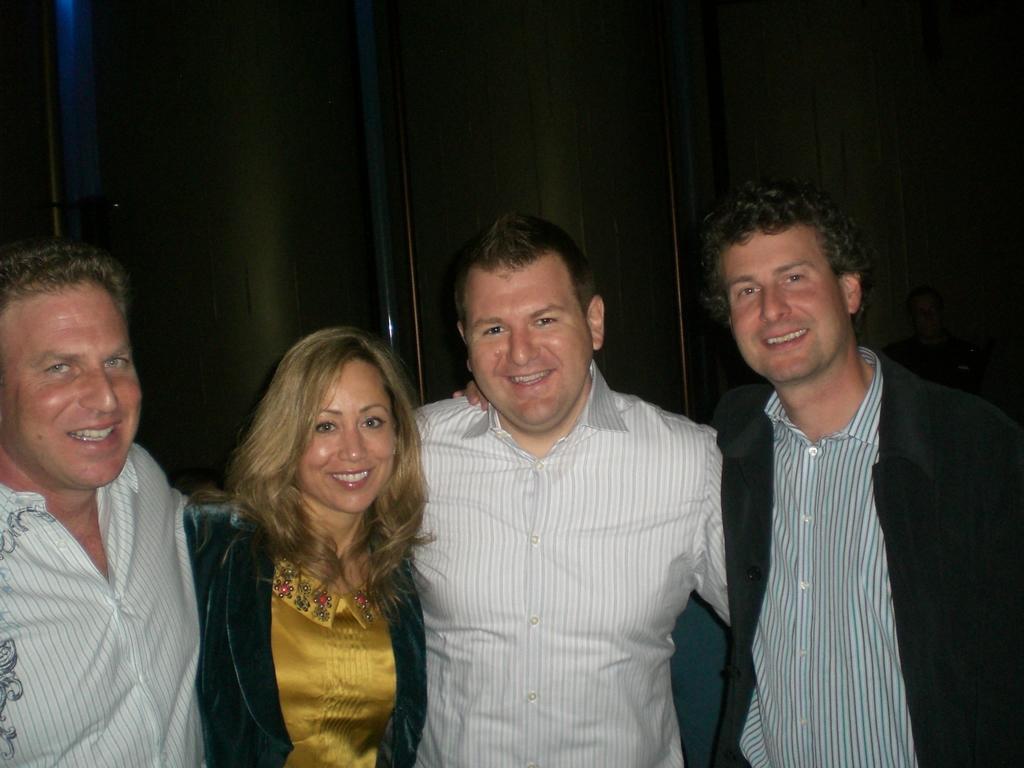In one or two sentences, can you explain what this image depicts? In the middle of the image few people are standing and smiling. Behind them there is a wall. 